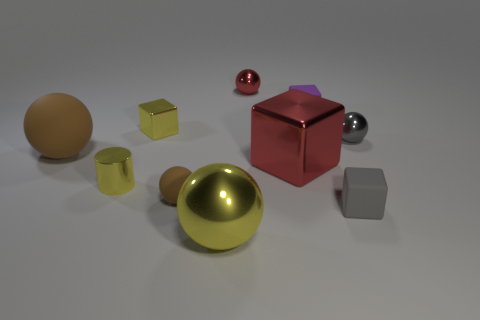Subtract all gray spheres. How many spheres are left? 4 Subtract all cylinders. How many objects are left? 9 Subtract all yellow blocks. How many blocks are left? 3 Subtract 5 spheres. How many spheres are left? 0 Add 3 small gray rubber objects. How many small gray rubber objects are left? 4 Add 7 tiny blocks. How many tiny blocks exist? 10 Subtract 0 blue cylinders. How many objects are left? 10 Subtract all yellow blocks. Subtract all cyan cylinders. How many blocks are left? 3 Subtract all purple cylinders. How many red balls are left? 1 Subtract all red balls. Subtract all tiny gray balls. How many objects are left? 8 